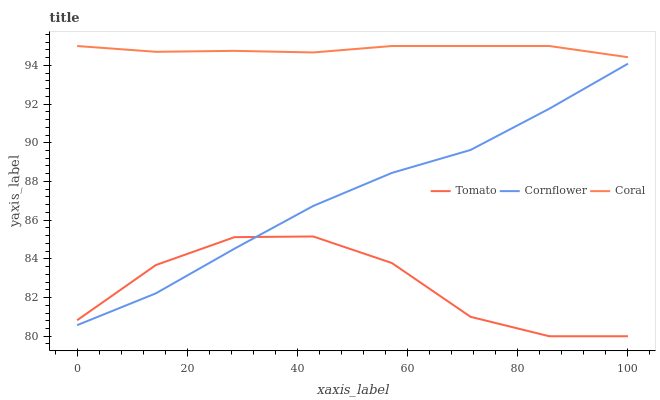Does Tomato have the minimum area under the curve?
Answer yes or no. Yes. Does Coral have the maximum area under the curve?
Answer yes or no. Yes. Does Cornflower have the minimum area under the curve?
Answer yes or no. No. Does Cornflower have the maximum area under the curve?
Answer yes or no. No. Is Coral the smoothest?
Answer yes or no. Yes. Is Tomato the roughest?
Answer yes or no. Yes. Is Cornflower the smoothest?
Answer yes or no. No. Is Cornflower the roughest?
Answer yes or no. No. Does Tomato have the lowest value?
Answer yes or no. Yes. Does Cornflower have the lowest value?
Answer yes or no. No. Does Coral have the highest value?
Answer yes or no. Yes. Does Cornflower have the highest value?
Answer yes or no. No. Is Tomato less than Coral?
Answer yes or no. Yes. Is Coral greater than Tomato?
Answer yes or no. Yes. Does Tomato intersect Cornflower?
Answer yes or no. Yes. Is Tomato less than Cornflower?
Answer yes or no. No. Is Tomato greater than Cornflower?
Answer yes or no. No. Does Tomato intersect Coral?
Answer yes or no. No. 